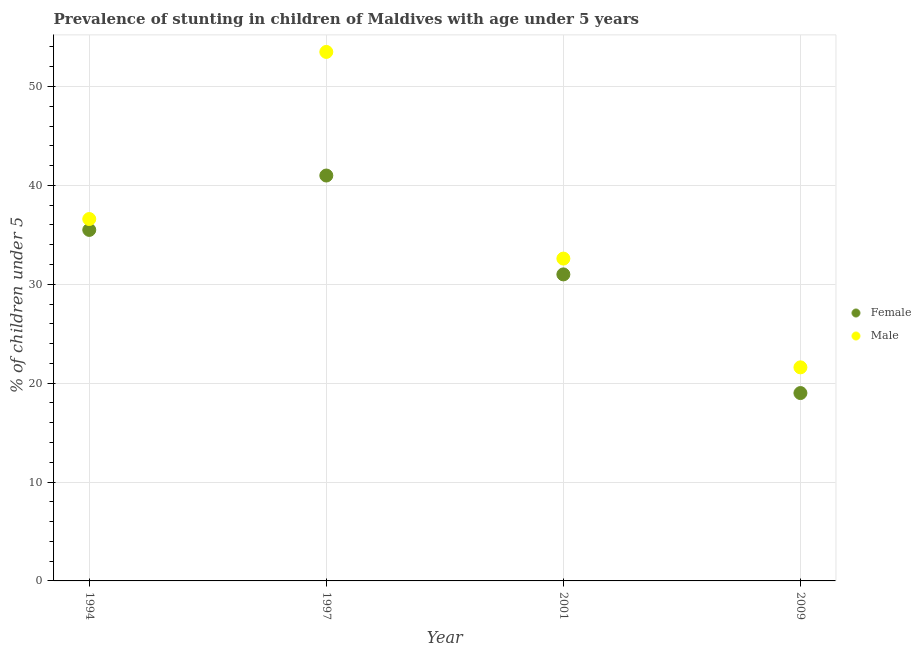Is the number of dotlines equal to the number of legend labels?
Ensure brevity in your answer.  Yes. Across all years, what is the maximum percentage of stunted male children?
Provide a short and direct response. 53.5. Across all years, what is the minimum percentage of stunted male children?
Your answer should be compact. 21.6. In which year was the percentage of stunted female children maximum?
Make the answer very short. 1997. In which year was the percentage of stunted male children minimum?
Your response must be concise. 2009. What is the total percentage of stunted male children in the graph?
Make the answer very short. 144.3. What is the difference between the percentage of stunted male children in 1994 and the percentage of stunted female children in 2001?
Offer a terse response. 5.6. What is the average percentage of stunted female children per year?
Ensure brevity in your answer.  31.62. In the year 2009, what is the difference between the percentage of stunted male children and percentage of stunted female children?
Your answer should be compact. 2.6. What is the ratio of the percentage of stunted female children in 1997 to that in 2001?
Offer a terse response. 1.32. Is the percentage of stunted male children in 1997 less than that in 2009?
Give a very brief answer. No. Is the sum of the percentage of stunted male children in 1997 and 2009 greater than the maximum percentage of stunted female children across all years?
Your answer should be compact. Yes. Does the percentage of stunted female children monotonically increase over the years?
Give a very brief answer. No. Is the percentage of stunted male children strictly greater than the percentage of stunted female children over the years?
Provide a succinct answer. Yes. Is the percentage of stunted female children strictly less than the percentage of stunted male children over the years?
Your answer should be compact. Yes. How many years are there in the graph?
Provide a short and direct response. 4. What is the difference between two consecutive major ticks on the Y-axis?
Your response must be concise. 10. Does the graph contain grids?
Offer a terse response. Yes. How many legend labels are there?
Offer a very short reply. 2. What is the title of the graph?
Give a very brief answer. Prevalence of stunting in children of Maldives with age under 5 years. Does "Frequency of shipment arrival" appear as one of the legend labels in the graph?
Make the answer very short. No. What is the label or title of the X-axis?
Ensure brevity in your answer.  Year. What is the label or title of the Y-axis?
Offer a very short reply.  % of children under 5. What is the  % of children under 5 of Female in 1994?
Provide a short and direct response. 35.5. What is the  % of children under 5 of Male in 1994?
Keep it short and to the point. 36.6. What is the  % of children under 5 of Male in 1997?
Provide a succinct answer. 53.5. What is the  % of children under 5 in Female in 2001?
Give a very brief answer. 31. What is the  % of children under 5 of Male in 2001?
Offer a terse response. 32.6. What is the  % of children under 5 in Male in 2009?
Make the answer very short. 21.6. Across all years, what is the maximum  % of children under 5 of Female?
Offer a terse response. 41. Across all years, what is the maximum  % of children under 5 in Male?
Your answer should be compact. 53.5. Across all years, what is the minimum  % of children under 5 in Male?
Your response must be concise. 21.6. What is the total  % of children under 5 of Female in the graph?
Offer a terse response. 126.5. What is the total  % of children under 5 of Male in the graph?
Offer a very short reply. 144.3. What is the difference between the  % of children under 5 of Male in 1994 and that in 1997?
Give a very brief answer. -16.9. What is the difference between the  % of children under 5 of Female in 1994 and that in 2001?
Offer a terse response. 4.5. What is the difference between the  % of children under 5 in Female in 1994 and that in 2009?
Ensure brevity in your answer.  16.5. What is the difference between the  % of children under 5 of Female in 1997 and that in 2001?
Give a very brief answer. 10. What is the difference between the  % of children under 5 in Male in 1997 and that in 2001?
Provide a succinct answer. 20.9. What is the difference between the  % of children under 5 in Male in 1997 and that in 2009?
Provide a succinct answer. 31.9. What is the difference between the  % of children under 5 of Female in 2001 and that in 2009?
Offer a very short reply. 12. What is the average  % of children under 5 in Female per year?
Give a very brief answer. 31.62. What is the average  % of children under 5 in Male per year?
Your answer should be compact. 36.08. In the year 1994, what is the difference between the  % of children under 5 in Female and  % of children under 5 in Male?
Ensure brevity in your answer.  -1.1. In the year 1997, what is the difference between the  % of children under 5 in Female and  % of children under 5 in Male?
Your answer should be compact. -12.5. What is the ratio of the  % of children under 5 in Female in 1994 to that in 1997?
Offer a very short reply. 0.87. What is the ratio of the  % of children under 5 of Male in 1994 to that in 1997?
Make the answer very short. 0.68. What is the ratio of the  % of children under 5 in Female in 1994 to that in 2001?
Provide a succinct answer. 1.15. What is the ratio of the  % of children under 5 in Male in 1994 to that in 2001?
Provide a succinct answer. 1.12. What is the ratio of the  % of children under 5 in Female in 1994 to that in 2009?
Your answer should be very brief. 1.87. What is the ratio of the  % of children under 5 of Male in 1994 to that in 2009?
Give a very brief answer. 1.69. What is the ratio of the  % of children under 5 in Female in 1997 to that in 2001?
Your answer should be compact. 1.32. What is the ratio of the  % of children under 5 in Male in 1997 to that in 2001?
Make the answer very short. 1.64. What is the ratio of the  % of children under 5 of Female in 1997 to that in 2009?
Give a very brief answer. 2.16. What is the ratio of the  % of children under 5 of Male in 1997 to that in 2009?
Offer a very short reply. 2.48. What is the ratio of the  % of children under 5 in Female in 2001 to that in 2009?
Your answer should be very brief. 1.63. What is the ratio of the  % of children under 5 in Male in 2001 to that in 2009?
Your answer should be compact. 1.51. What is the difference between the highest and the second highest  % of children under 5 in Female?
Ensure brevity in your answer.  5.5. What is the difference between the highest and the lowest  % of children under 5 of Male?
Offer a terse response. 31.9. 